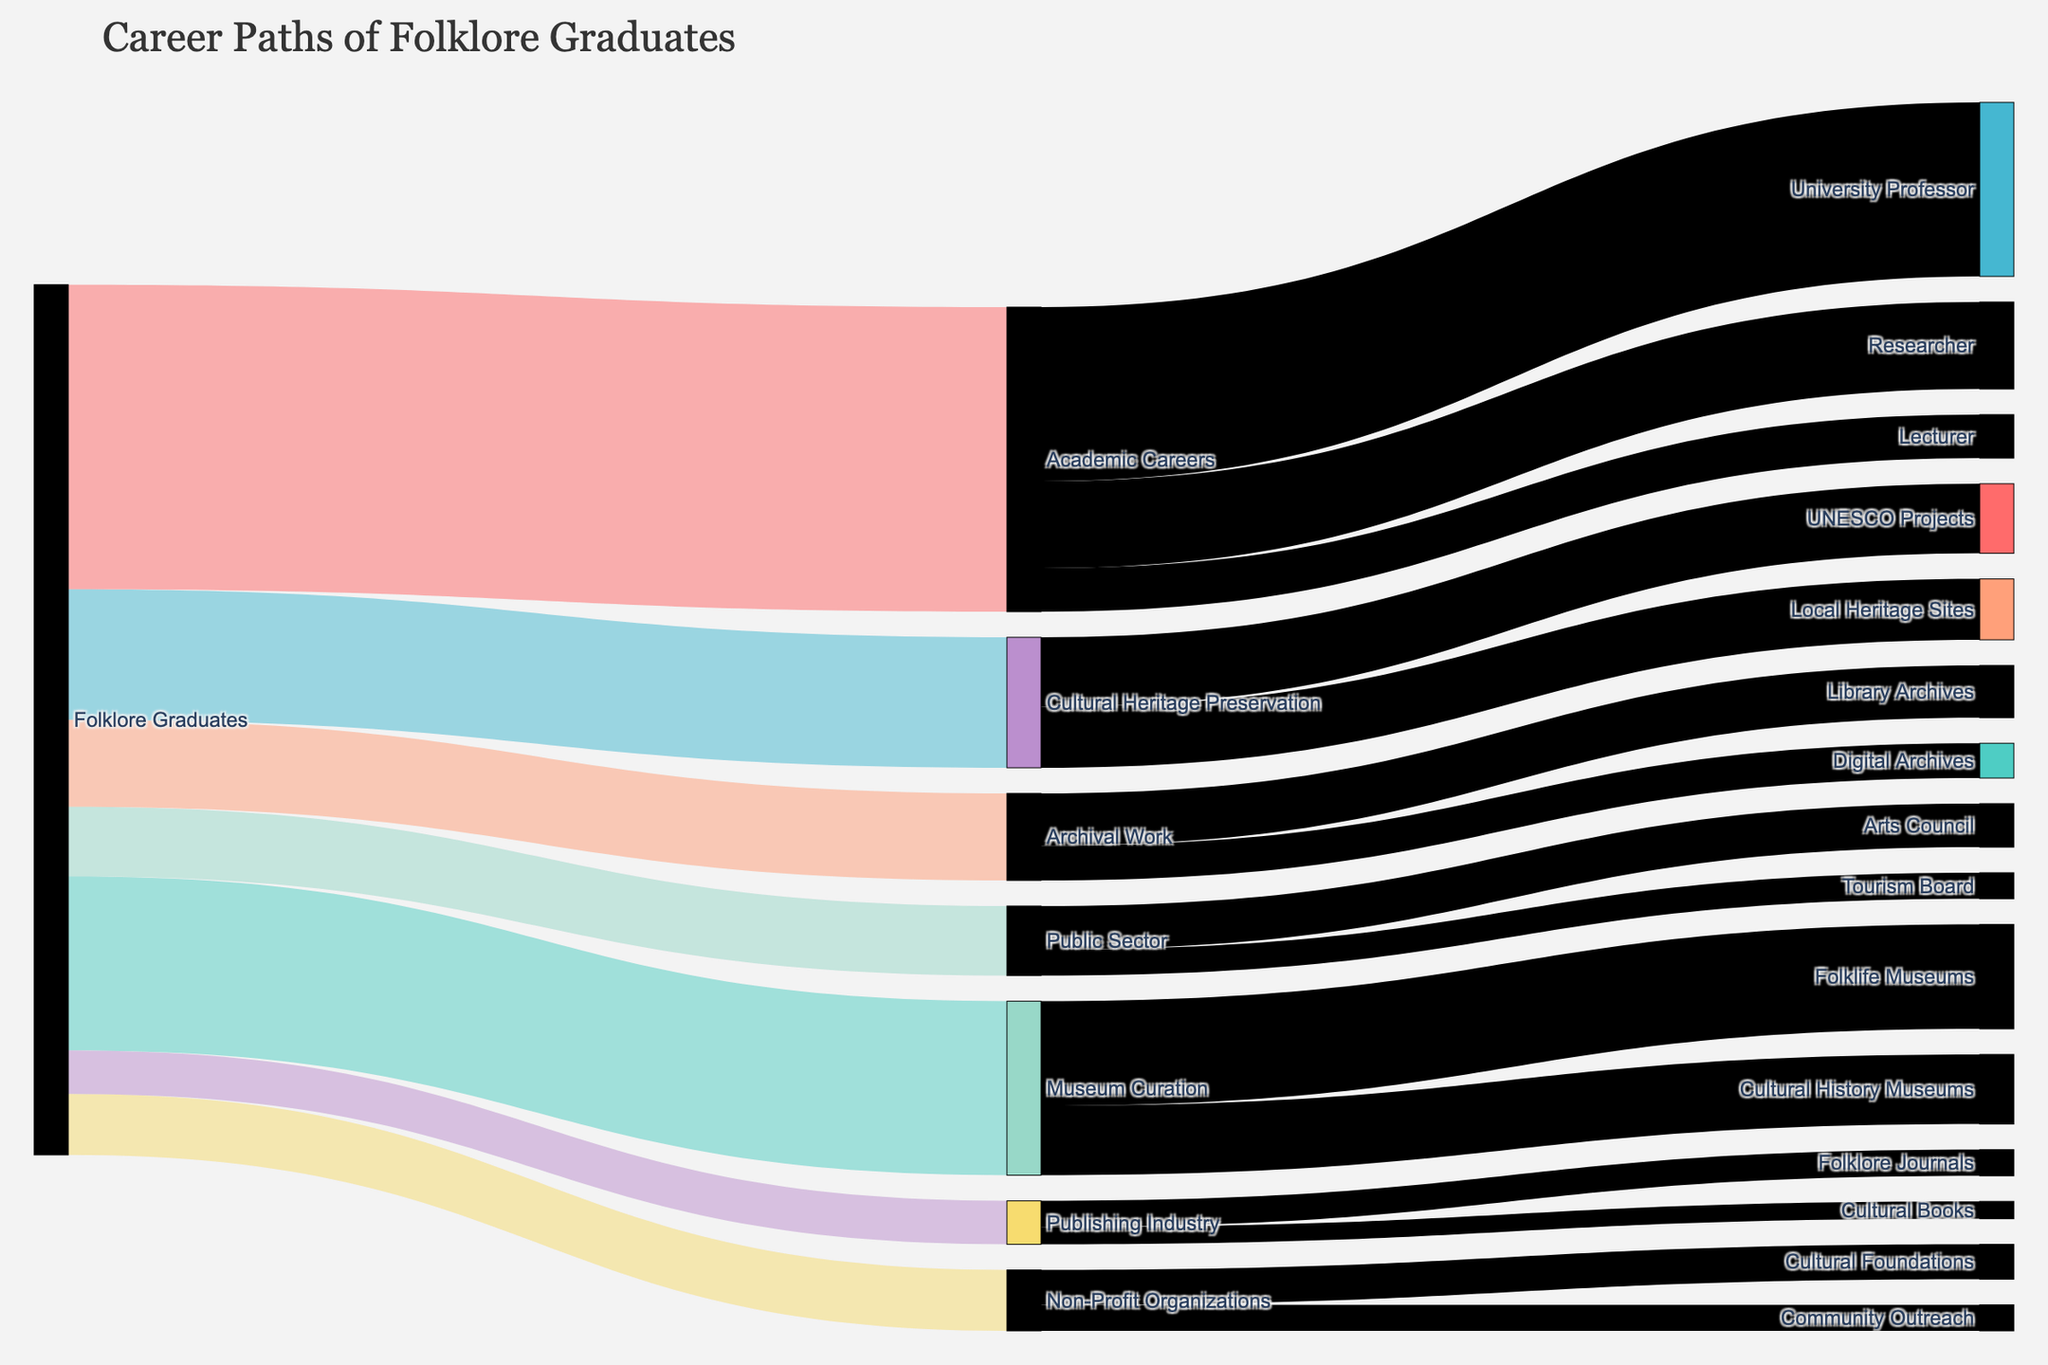How many folklore graduates pursued academic careers? To find this, look at the link labeled "Folklore Graduates" leading to "Academic Careers." The value associated with this link indicates the number of graduates who pursued academic careers.
Answer: 35 Which target category received the fewest folklore graduates? Examine all the targets originating from "Folklore Graduates" and identify the one with the smallest value. The publishing industry has the least number of graduates.
Answer: Publishing Industry What is the total number of folklore graduates who ended up in Museum Curation and Cultural Heritage Preservation combined? Add the values from "Folklore Graduates" to "Museum Curation" and "Folklore Graduates" to "Cultural Heritage Preservation." The values are 20 and 15, respectively. Summing these gives 20 + 15 = 35.
Answer: 35 Who has more graduates: Public Sector or Non-Profit Organizations? Compare the values from "Folklore Graduates" to "Public Sector" and "Folklore Graduates" to "Non-Profit Organizations." The values are 8 and 7, respectively, indicating the Public Sector has more graduates.
Answer: Public Sector Which sub-category under Academic Careers has the highest number of graduates? Look at the links from "Academic Careers" to its sub-categories: "University Professor," "Researcher," and "Lecturer." The value for "University Professor" is the highest at 20.
Answer: University Professor How many graduates are working with UNESCO Projects? To find this, look for the value from "Cultural Heritage Preservation" to "UNESCO Projects." The value is 8.
Answer: 8 What is the combined number of graduates involved in Archival Work? Add up the values from "Folklore Graduates" to "Archival Work," "Library Archives," and "Digital Archives." The values are 10, 6, and 4, respectively. Summing these gives 10 + 6 + 4 = 20.
Answer: 20 Which career path has more graduates: Folklife Museums or Cultural History Museums? Look at the links from "Museum Curation" to "Folklife Museums" and "Cultural History Museums." The values are 12 and 8 respectively, showing Folklife Museums have more graduates.
Answer: Folklife Museums What percentage of folklore graduates went into the Public Sector? Calculate the percentage by dividing the value for "Public Sector" by the total number of folklore graduates and multiplying by 100. The Public Sector has 8 out of a total of 100 graduates (35 + 20 + 15 + 10 + 8 + 7 + 5 = 100). (8 / 100) * 100 = 8%.
Answer: 8% What is the total number of graduates involved in Publishing Industry sub-categories? Add the values from "Publishing Industry" to "Folklore Journals" and "Cultural Books." The values are 3 and 2, respectively. Summing these gives 3 + 2 = 5.
Answer: 5 